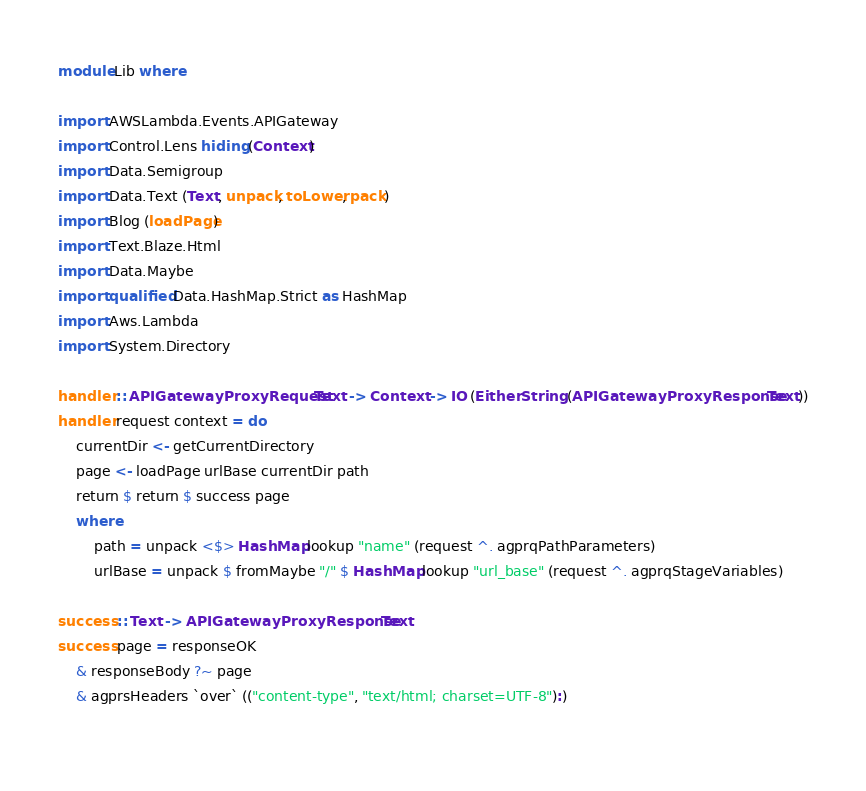Convert code to text. <code><loc_0><loc_0><loc_500><loc_500><_Haskell_>module Lib where

import AWSLambda.Events.APIGateway
import Control.Lens hiding (Context)
import Data.Semigroup
import Data.Text (Text, unpack, toLower, pack)
import Blog (loadPage)
import Text.Blaze.Html
import Data.Maybe
import qualified Data.HashMap.Strict as HashMap
import Aws.Lambda
import System.Directory

handler :: APIGatewayProxyRequest Text -> Context -> IO (Either String (APIGatewayProxyResponse Text))
handler request context = do
    currentDir <- getCurrentDirectory
    page <- loadPage urlBase currentDir path
    return $ return $ success page
    where
        path = unpack <$> HashMap.lookup "name" (request ^. agprqPathParameters)
        urlBase = unpack $ fromMaybe "/" $ HashMap.lookup "url_base" (request ^. agprqStageVariables)

success :: Text -> APIGatewayProxyResponse Text
success page = responseOK 
    & responseBody ?~ page
    & agprsHeaders `over` (("content-type", "text/html; charset=UTF-8"):)
    </code> 